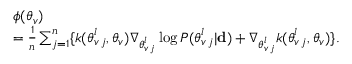Convert formula to latex. <formula><loc_0><loc_0><loc_500><loc_500>\begin{array} { r l } & { \phi ( \theta _ { v } ) } \\ & { = \frac { 1 } { n } \sum _ { j = 1 } ^ { n } \{ k ( \theta _ { v \, j } ^ { l } , \theta _ { v } ) \nabla _ { \theta _ { v \, j } ^ { l } } \log P ( \theta _ { v \, j } ^ { l } | { d } ) + \nabla _ { \theta _ { v \, j } ^ { l } } k ( \theta _ { v \, j } ^ { l } , \theta _ { v } ) \} . } \end{array}</formula> 